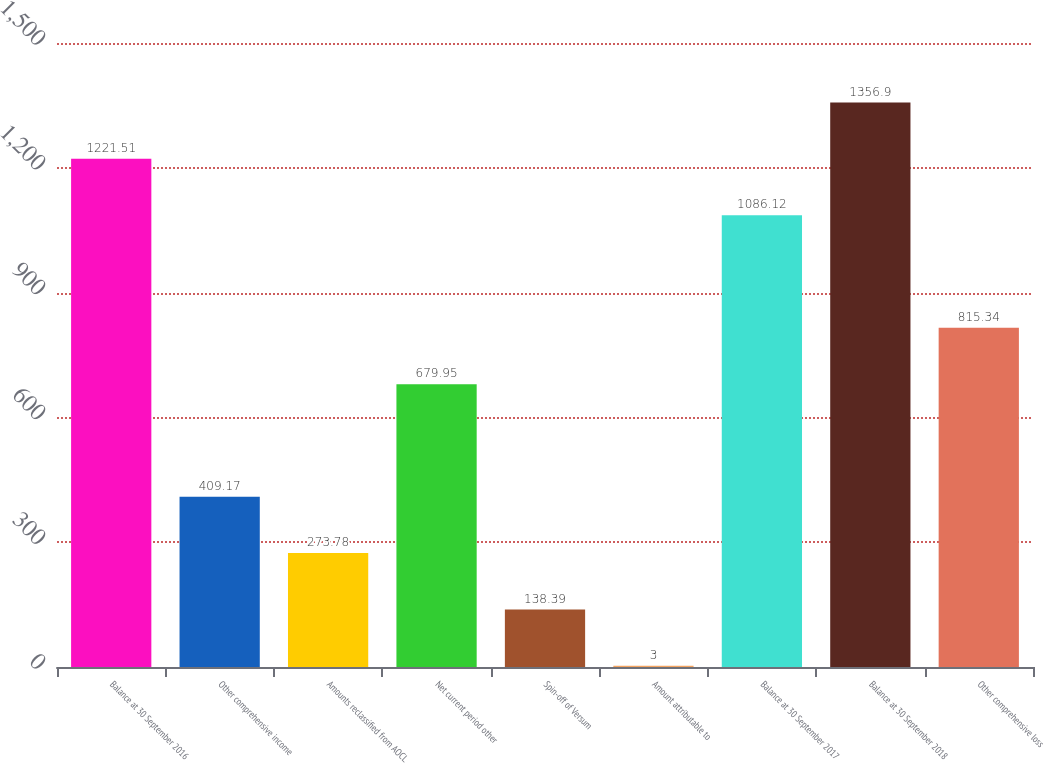<chart> <loc_0><loc_0><loc_500><loc_500><bar_chart><fcel>Balance at 30 September 2016<fcel>Other comprehensive income<fcel>Amounts reclassified from AOCL<fcel>Net current period other<fcel>Spin-off of Versum<fcel>Amount attributable to<fcel>Balance at 30 September 2017<fcel>Balance at 30 September 2018<fcel>Other comprehensive loss<nl><fcel>1221.51<fcel>409.17<fcel>273.78<fcel>679.95<fcel>138.39<fcel>3<fcel>1086.12<fcel>1356.9<fcel>815.34<nl></chart> 